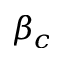<formula> <loc_0><loc_0><loc_500><loc_500>\beta _ { c }</formula> 